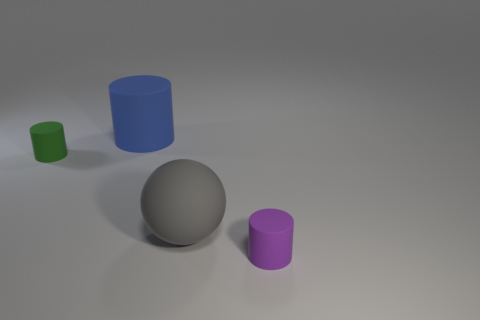Add 2 gray matte spheres. How many objects exist? 6 Subtract all spheres. How many objects are left? 3 Subtract 1 purple cylinders. How many objects are left? 3 Subtract all large matte things. Subtract all blue matte objects. How many objects are left? 1 Add 2 matte cylinders. How many matte cylinders are left? 5 Add 2 small cyan rubber cylinders. How many small cyan rubber cylinders exist? 2 